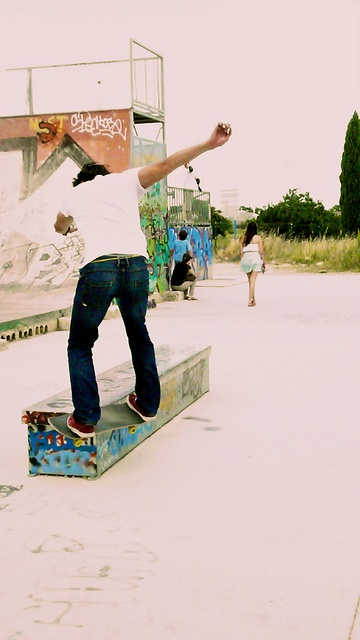Describe the objects in this image and their specific colors. I can see people in lightgray, black, gray, and tan tones, bench in lightgray, tan, darkgray, and teal tones, skateboard in lightgray, gray, olive, darkgreen, and black tones, people in lightgray, black, and tan tones, and people in lightgray, black, tan, and olive tones in this image. 